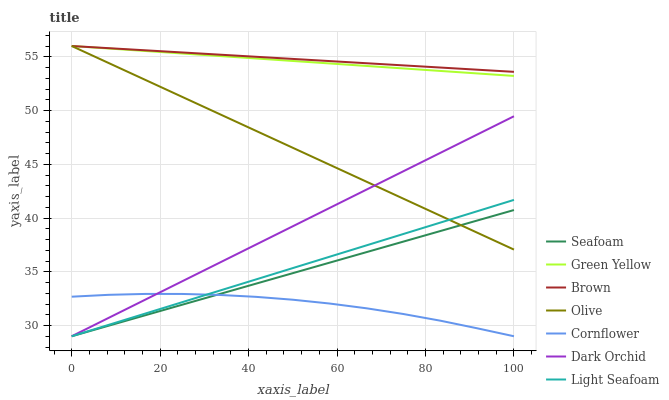Does Cornflower have the minimum area under the curve?
Answer yes or no. Yes. Does Brown have the maximum area under the curve?
Answer yes or no. Yes. Does Light Seafoam have the minimum area under the curve?
Answer yes or no. No. Does Light Seafoam have the maximum area under the curve?
Answer yes or no. No. Is Light Seafoam the smoothest?
Answer yes or no. Yes. Is Cornflower the roughest?
Answer yes or no. Yes. Is Cornflower the smoothest?
Answer yes or no. No. Is Light Seafoam the roughest?
Answer yes or no. No. Does Light Seafoam have the lowest value?
Answer yes or no. Yes. Does Olive have the lowest value?
Answer yes or no. No. Does Green Yellow have the highest value?
Answer yes or no. Yes. Does Light Seafoam have the highest value?
Answer yes or no. No. Is Light Seafoam less than Brown?
Answer yes or no. Yes. Is Brown greater than Cornflower?
Answer yes or no. Yes. Does Seafoam intersect Light Seafoam?
Answer yes or no. Yes. Is Seafoam less than Light Seafoam?
Answer yes or no. No. Is Seafoam greater than Light Seafoam?
Answer yes or no. No. Does Light Seafoam intersect Brown?
Answer yes or no. No. 